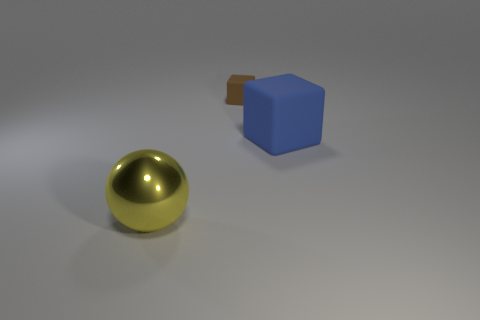There is another block that is the same material as the small brown block; what color is it?
Your answer should be compact. Blue. Are there an equal number of brown objects right of the big yellow shiny ball and cyan objects?
Make the answer very short. No. What shape is the blue rubber object that is the same size as the metallic object?
Keep it short and to the point. Cube. How many other objects are there of the same shape as the tiny matte object?
Offer a terse response. 1. Do the brown matte cube and the rubber object in front of the brown matte thing have the same size?
Provide a short and direct response. No. What number of things are either blocks in front of the tiny brown rubber block or metal things?
Provide a succinct answer. 2. There is a matte object that is behind the big blue rubber cube; what shape is it?
Provide a short and direct response. Cube. Are there the same number of brown blocks that are to the left of the yellow shiny ball and yellow balls behind the brown rubber cube?
Your response must be concise. Yes. What color is the thing that is on the left side of the big block and right of the big yellow sphere?
Offer a terse response. Brown. What is the material of the cube that is behind the matte thing that is on the right side of the small brown cube?
Offer a terse response. Rubber. 